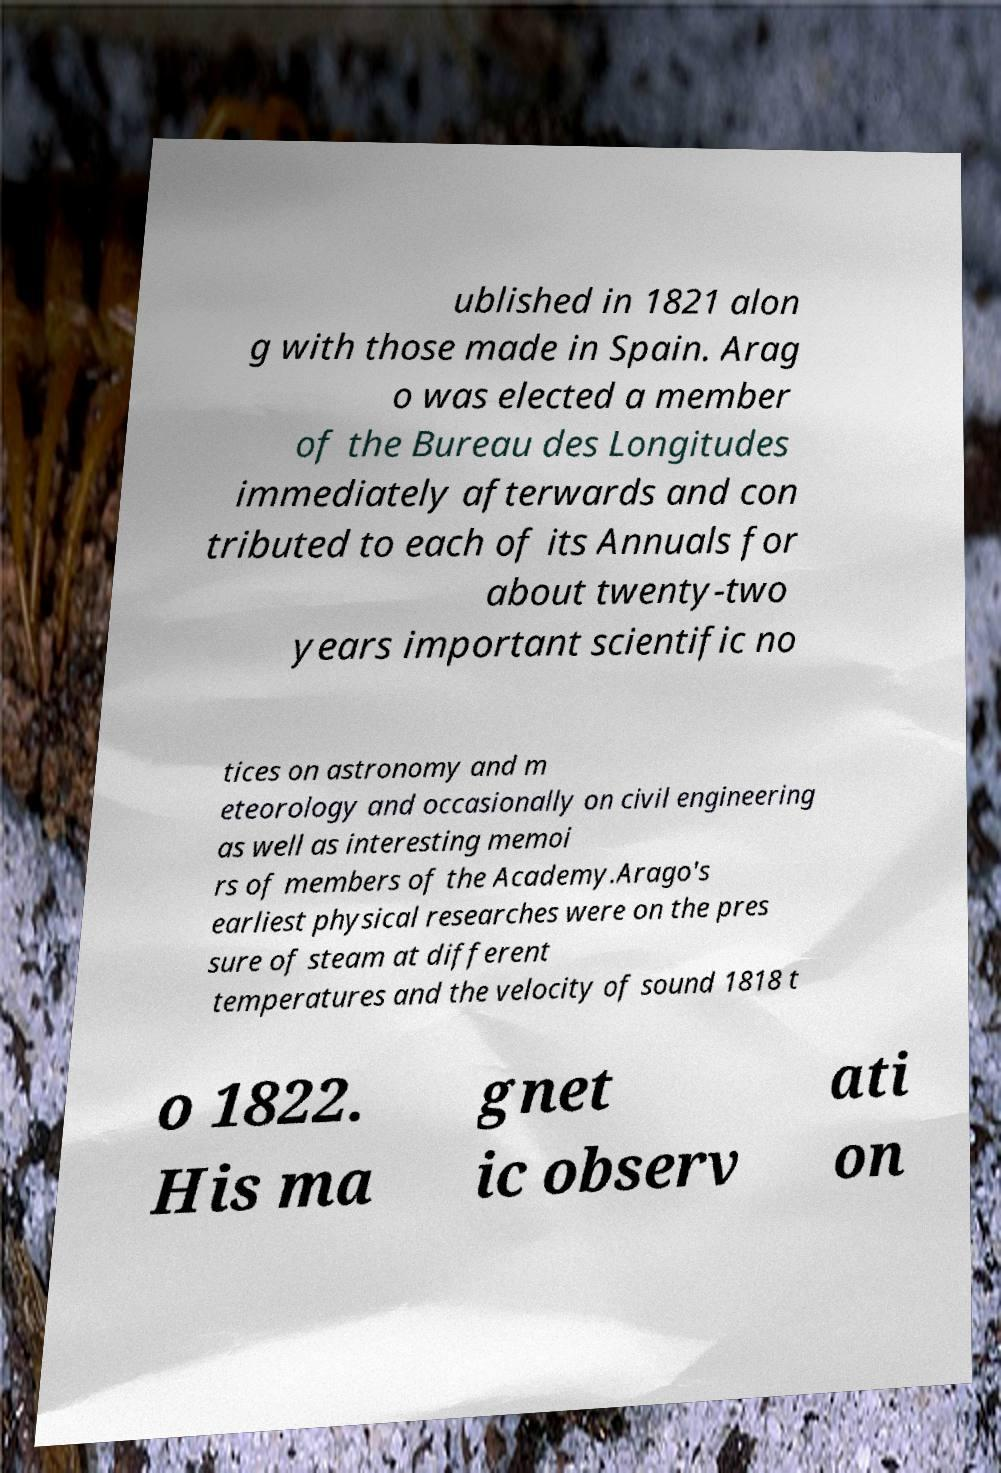Could you assist in decoding the text presented in this image and type it out clearly? ublished in 1821 alon g with those made in Spain. Arag o was elected a member of the Bureau des Longitudes immediately afterwards and con tributed to each of its Annuals for about twenty-two years important scientific no tices on astronomy and m eteorology and occasionally on civil engineering as well as interesting memoi rs of members of the Academy.Arago's earliest physical researches were on the pres sure of steam at different temperatures and the velocity of sound 1818 t o 1822. His ma gnet ic observ ati on 